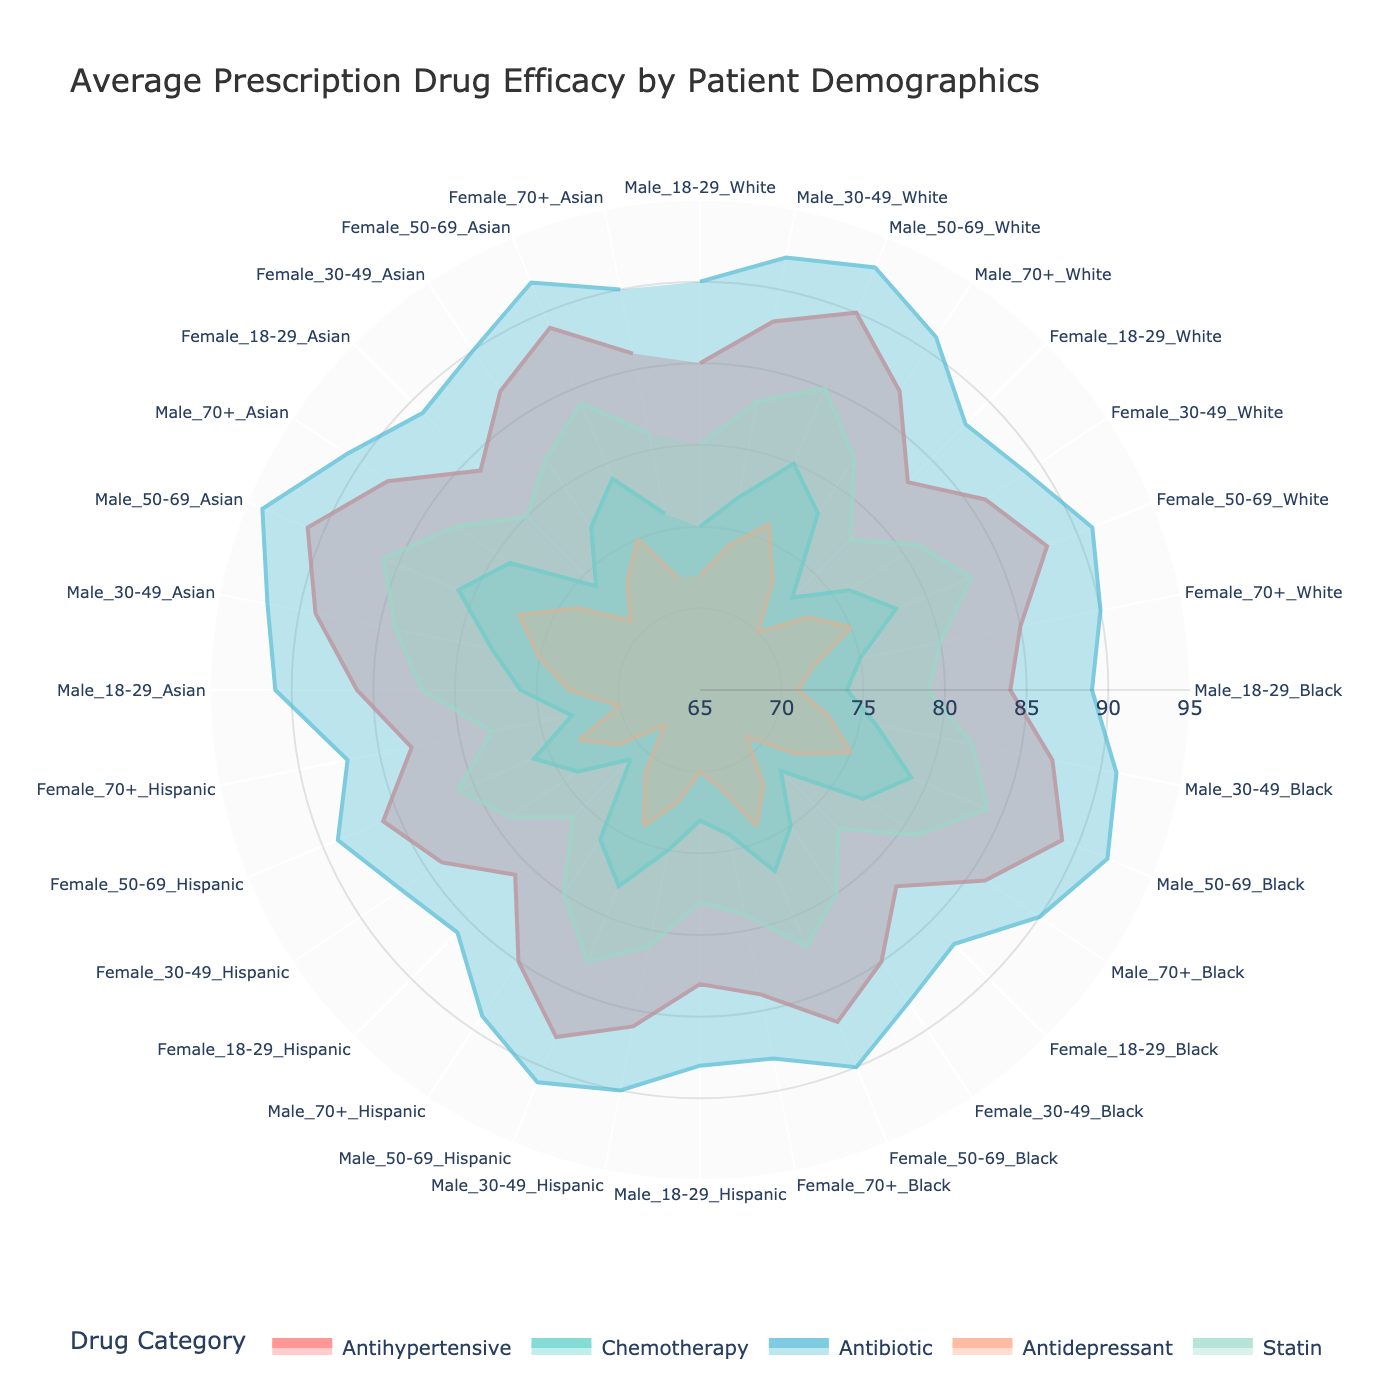What's the title of the figure? The title of the figure is displayed at the top of the chart, which describes the main subject of the visualization.
Answer: Average Prescription Drug Efficacy by Patient Demographics Which drug category has the highest efficacy for Male 50-69 White? For Male 50-69 White, the highest efficacy can be determined by locating the appropriate section in the demographic axis and comparing the values. The category with the highest value is Antibiotic.
Answer: Antibiotic What is the average efficacy of Antidepressants across all demographics? To find this, identify the efficacy values for Antidepressants across all demographics, sum them up, and divide by the number of entries. The calculation would be (72+74+76+73+70+73+75+72+71+73+75+72+69+72+74+71+70+72+74+71+68+71+73+70+73+75+77+74+71+73+75+72)/32.
Answer: 72.96 Compare the efficacy of Statins between Male 30-49 Black and Female 30-49 Asian. Which one is higher? Look at the values for Statin efficacy under the respective demographics. For Male 30-49 Black, it is 82, and for Female 30-49 Asian, it is 82 as well. They are equal.
Answer: Equal How does the efficacy of Antihypertensives for Male 18-29 Asian compare to Female 18-29 Hispanic? Locate the efficacy values for Antihypertensives for the specified demographics. For Male 18-29 Asian, it's 86, and for Female 18-29 Hispanic, it's 81. Male 18-29 Asian is higher.
Answer: Male 18-29 Asian is higher Which demographic has the lowest Chemotherapy efficacy? Compare the Chemotherapy efficacy values across all demographics to identify the lowest one. Female 18-29 Hispanic has the lowest efficacy, which is 71.
Answer: Female 18-29 Hispanic Identify the drug category with the smallest efficacy range across different demographics. Calculate the range for each drug category by subtracting the minimum efficacy value from the maximum efficacy value. Compare these ranges to find the smallest one. Antibiotic's range is (94-86 = 8) which is the smallest.
Answer: Antibiotic What is the range of Antibiotic efficacy for the Asian demographic group? To find the range, identify the highest and lowest Antibiotic efficacy values within the Asian demographic group. The values are 94 and 89 respectively, so the range is 94 - 89.
Answer: 5 Are there any drug categories where Female 50-69 perform better than Male 50-69 across all ethnicities? Compare each drug category's efficacy values for Female 50-69 to Male 50-69 across all ethnicities. Female 50-69 consistently has the same or lower efficacy, so there isn't any category performing better.
Answer: No Which ethnicity shows the highest overall efficacy for Chemotherapy when combining both genders and all age groups? Average the Chemotherapy efficacy values for all age and gender groups within each ethnicity and compare the results. Asian ethnicity shows the highest average efficacy in Chemotherapy (average of 76.5).
Answer: Asian 